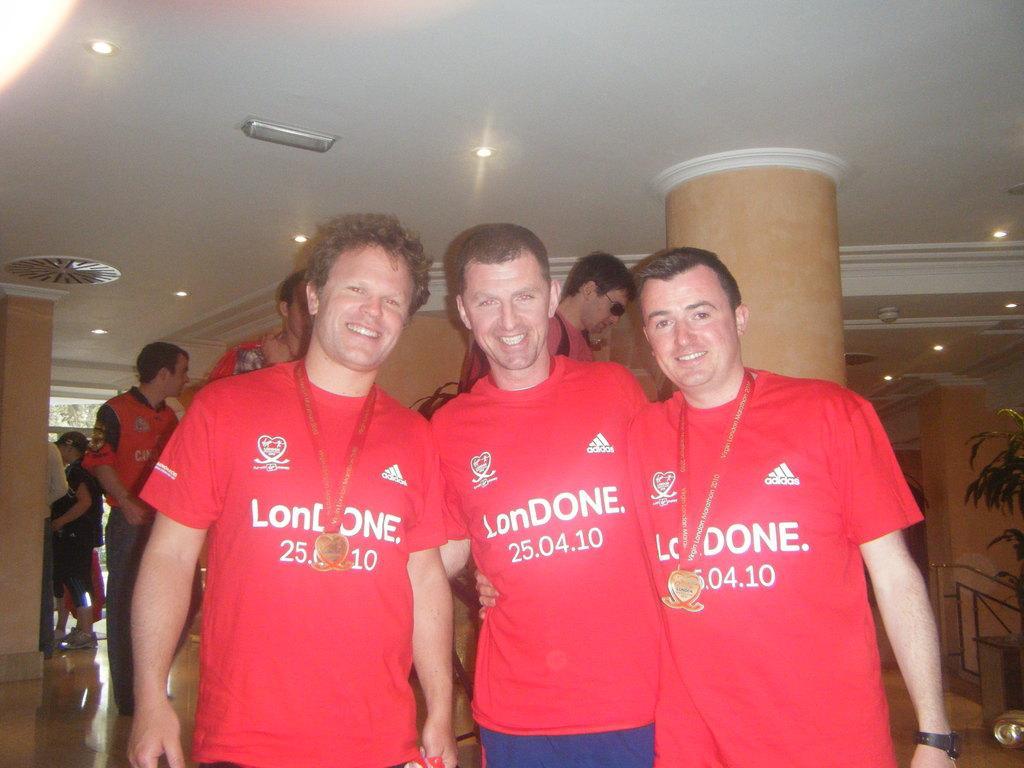In one or two sentences, can you explain what this image depicts? In this image I can see three persons wearing red t shirt are standing beside each other. In the background I can see few other persons standing, a pillar which is brown in color, a tree, the ceiling and few lights to the ceiling. 